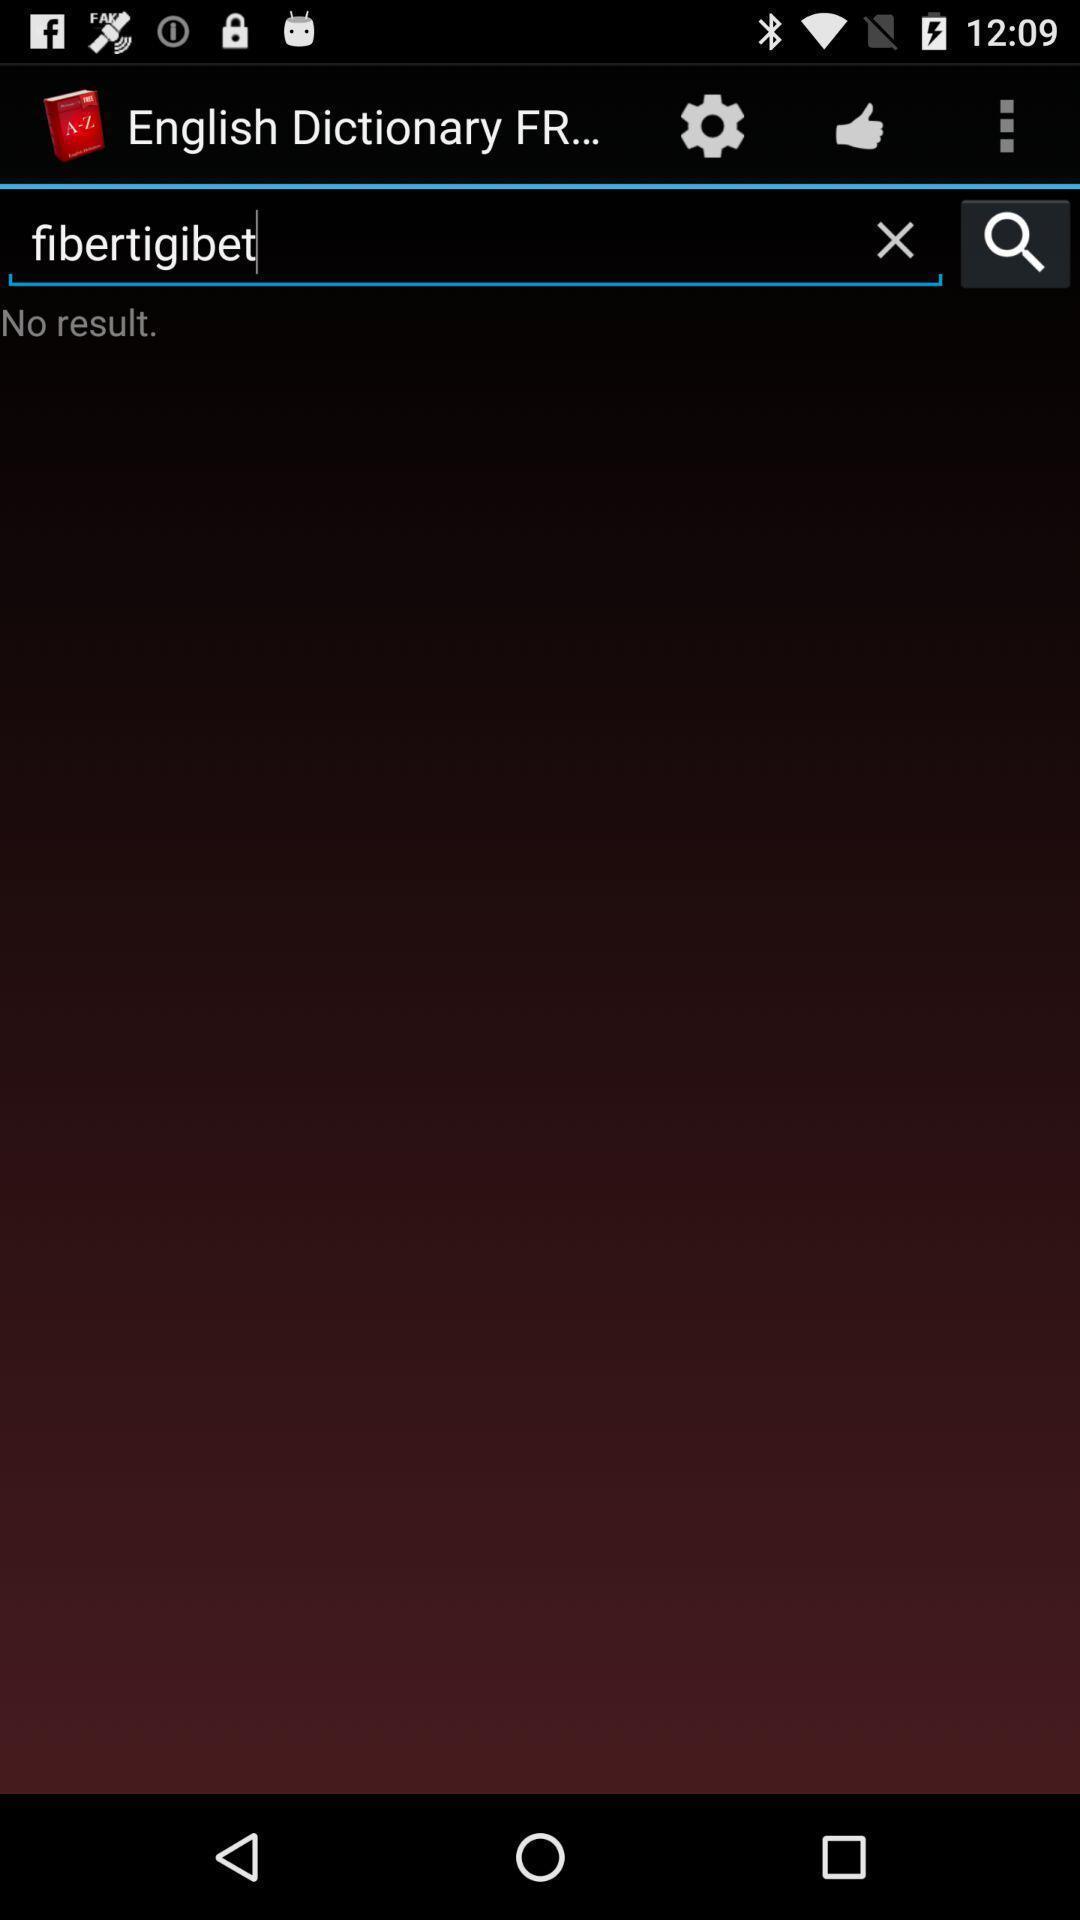Explain what's happening in this screen capture. Search option of an offline english dictionary app. 